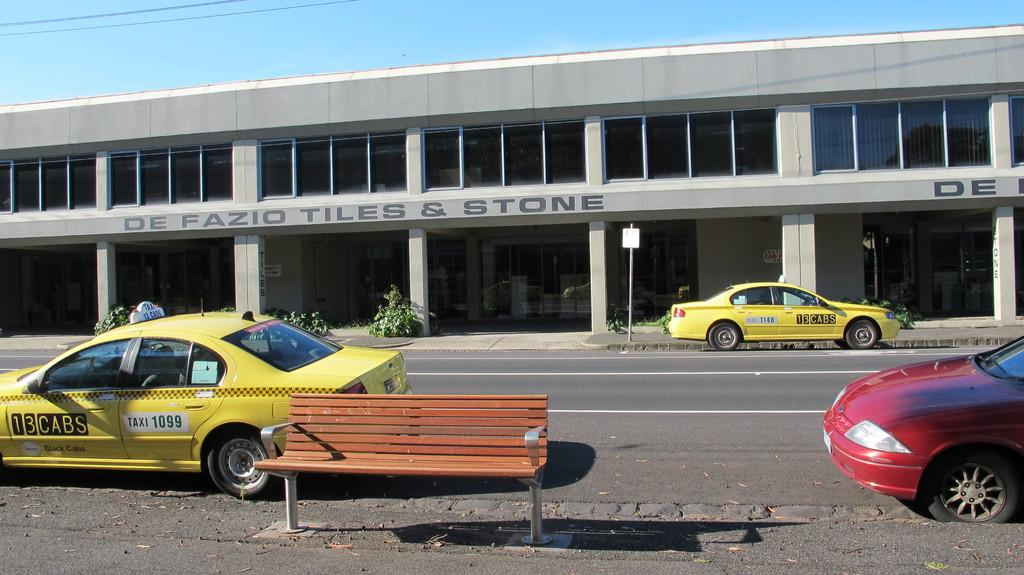<image>
Create a compact narrative representing the image presented. Yellow cabs from 13 Cabs sit on a street i front of a  two story building occupied by De Fazio Tiles & Stone 